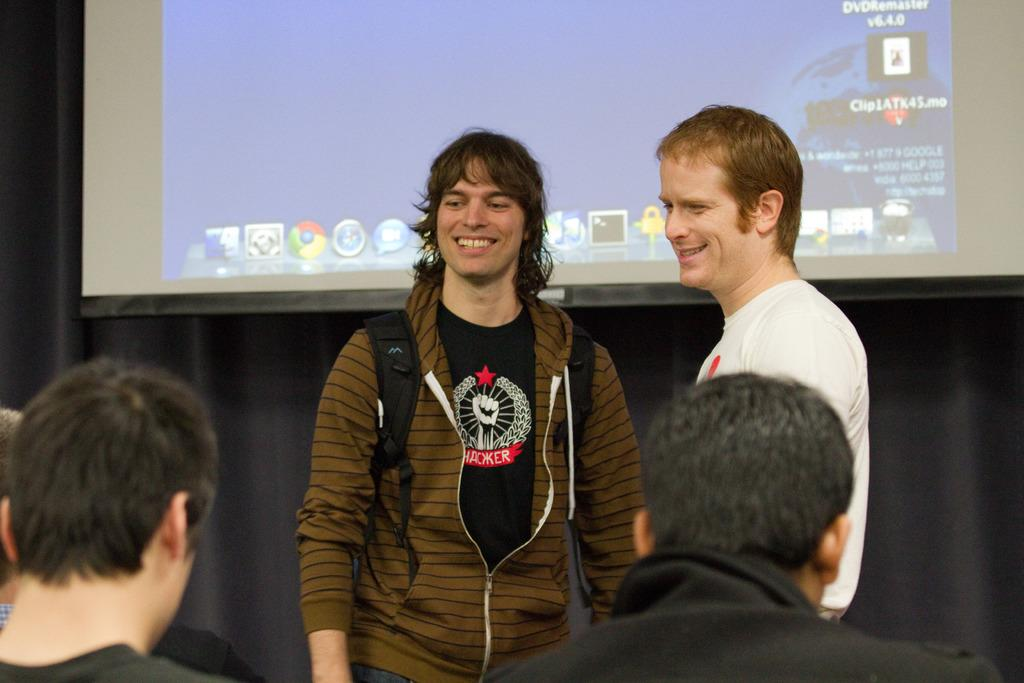How many people are visible in the image? There are many people in the image. What is the person in the center wearing? The person in the center is wearing a jacket. What is the person in the center carrying? The person in the center is carrying a bag. What can be seen in the background of the image? There is a screen and a curtain in the background of the image. What type of slope can be seen in the image? There is no slope present in the image. How does friction affect the movement of the people in the image? The image does not provide information about friction or the movement of the people, so it cannot be determined. 